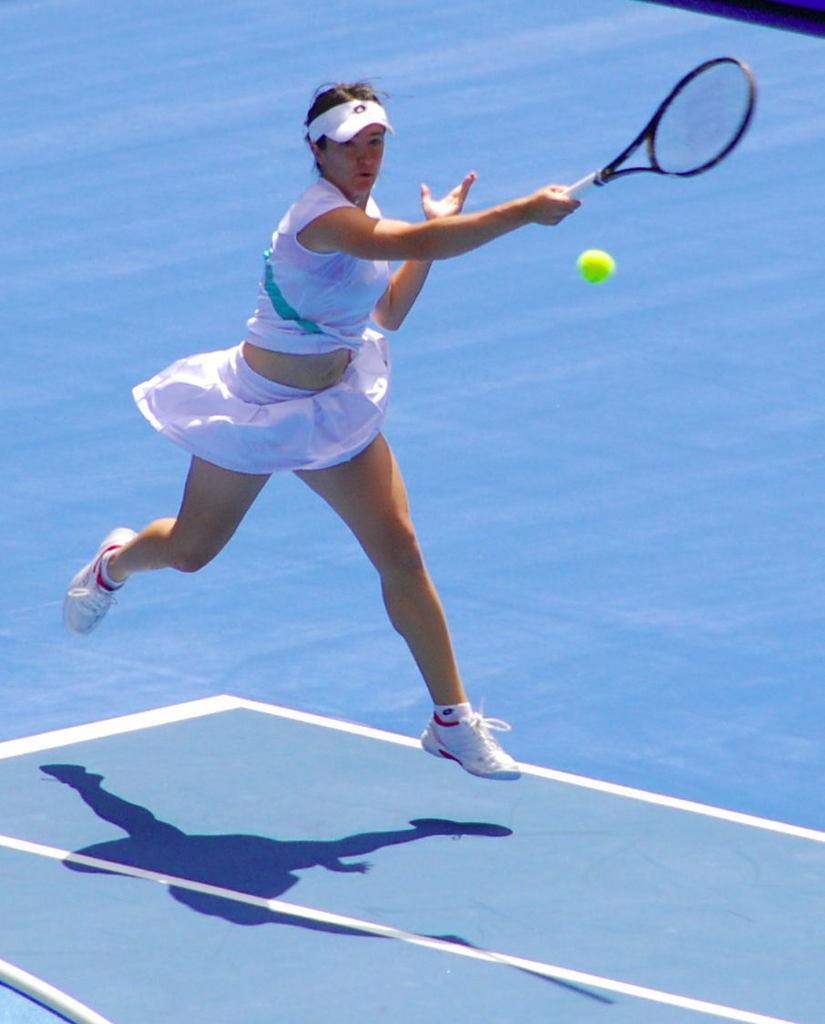Could you give a brief overview of what you see in this image? In this picture there is a woman playing a badminton tennis in the court. 